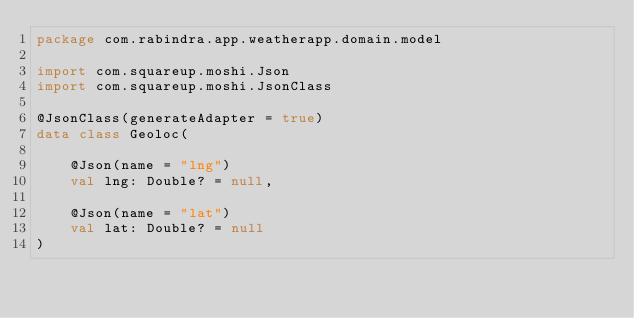<code> <loc_0><loc_0><loc_500><loc_500><_Kotlin_>package com.rabindra.app.weatherapp.domain.model

import com.squareup.moshi.Json
import com.squareup.moshi.JsonClass

@JsonClass(generateAdapter = true)
data class Geoloc(

    @Json(name = "lng")
    val lng: Double? = null,

    @Json(name = "lat")
    val lat: Double? = null
)
</code> 